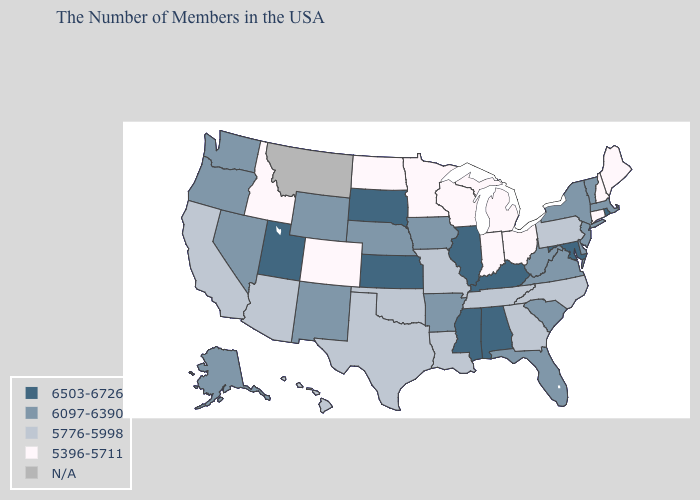What is the lowest value in the MidWest?
Keep it brief. 5396-5711. What is the lowest value in states that border Ohio?
Quick response, please. 5396-5711. What is the value of Arizona?
Write a very short answer. 5776-5998. What is the lowest value in the West?
Answer briefly. 5396-5711. Which states have the lowest value in the USA?
Keep it brief. Maine, New Hampshire, Connecticut, Ohio, Michigan, Indiana, Wisconsin, Minnesota, North Dakota, Colorado, Idaho. Does the first symbol in the legend represent the smallest category?
Quick response, please. No. What is the value of Mississippi?
Give a very brief answer. 6503-6726. Name the states that have a value in the range 6503-6726?
Answer briefly. Rhode Island, Maryland, Kentucky, Alabama, Illinois, Mississippi, Kansas, South Dakota, Utah. What is the value of Nebraska?
Give a very brief answer. 6097-6390. What is the highest value in states that border Arizona?
Answer briefly. 6503-6726. Does Tennessee have the highest value in the South?
Be succinct. No. Name the states that have a value in the range 5396-5711?
Concise answer only. Maine, New Hampshire, Connecticut, Ohio, Michigan, Indiana, Wisconsin, Minnesota, North Dakota, Colorado, Idaho. What is the highest value in the South ?
Give a very brief answer. 6503-6726. What is the value of New Hampshire?
Give a very brief answer. 5396-5711. 